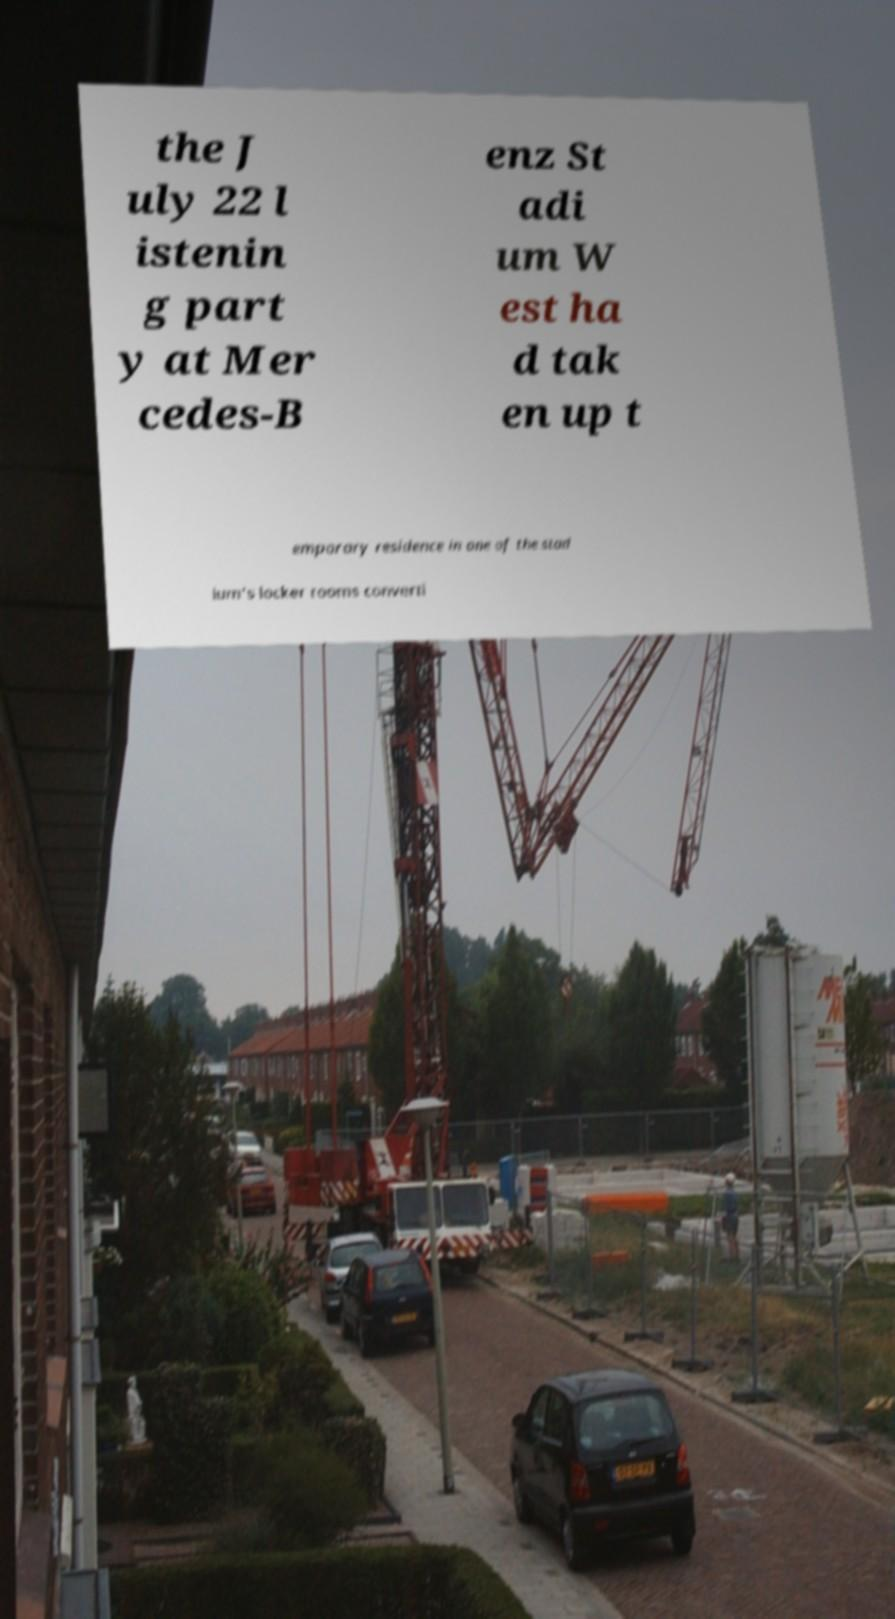For documentation purposes, I need the text within this image transcribed. Could you provide that? the J uly 22 l istenin g part y at Mer cedes-B enz St adi um W est ha d tak en up t emporary residence in one of the stad ium's locker rooms converti 